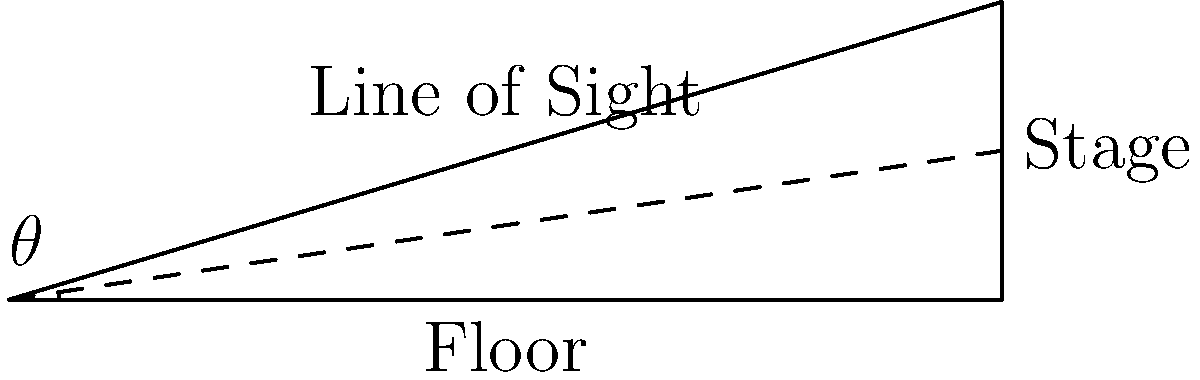For a tiered seating arrangement in a meet-and-greet event, you need to calculate the angle of the sloped floor for proper visibility. If the distance from the first row to the stage is 10 meters and the stage is elevated 3 meters above the floor level, what is the minimum angle $\theta$ (in degrees) required for the sloped floor to ensure clear sightlines for all attendees? To solve this problem, we need to follow these steps:

1. Identify the right triangle formed by the floor, stage height, and line of sight.
2. Use the tangent function to calculate the angle.
3. Convert the result from radians to degrees.

Step 1: The right triangle is formed with:
- Base (adjacent) = 10 meters (distance to stage)
- Height (opposite) = 3 meters (stage elevation)
- Hypotenuse = line of sight

Step 2: Calculate the angle using the tangent function:
$$\tan(\theta) = \frac{\text{opposite}}{\text{adjacent}} = \frac{3}{10} = 0.3$$

$$\theta = \arctan(0.3)$$

Step 3: Convert the result from radians to degrees:
$$\theta = \arctan(0.3) \cdot \frac{180^{\circ}}{\pi} \approx 16.70^{\circ}$$

Therefore, the minimum angle required for the sloped floor is approximately 16.70°.
Answer: $16.70^{\circ}$ 